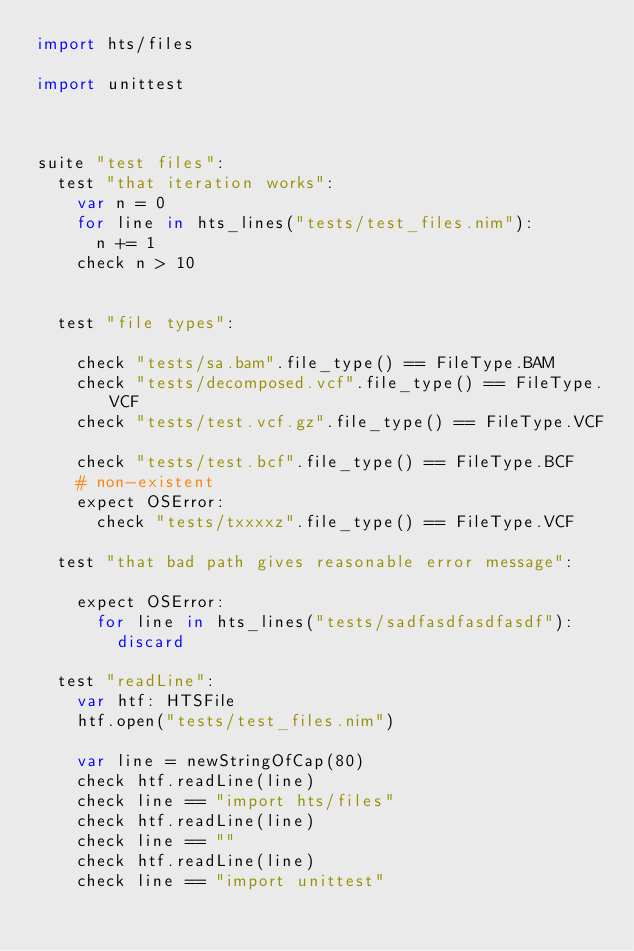<code> <loc_0><loc_0><loc_500><loc_500><_Nim_>import hts/files

import unittest



suite "test files":
  test "that iteration works":
    var n = 0
    for line in hts_lines("tests/test_files.nim"):
      n += 1
    check n > 10


  test "file types":

    check "tests/sa.bam".file_type() == FileType.BAM
    check "tests/decomposed.vcf".file_type() == FileType.VCF
    check "tests/test.vcf.gz".file_type() == FileType.VCF

    check "tests/test.bcf".file_type() == FileType.BCF
    # non-existent
    expect OSError:
      check "tests/txxxxz".file_type() == FileType.VCF

  test "that bad path gives reasonable error message":

    expect OSError:
      for line in hts_lines("tests/sadfasdfasdfasdf"):
        discard

  test "readLine":
    var htf: HTSFile
    htf.open("tests/test_files.nim")

    var line = newStringOfCap(80)
    check htf.readLine(line)
    check line == "import hts/files"
    check htf.readLine(line)
    check line == ""
    check htf.readLine(line)
    check line == "import unittest"
</code> 